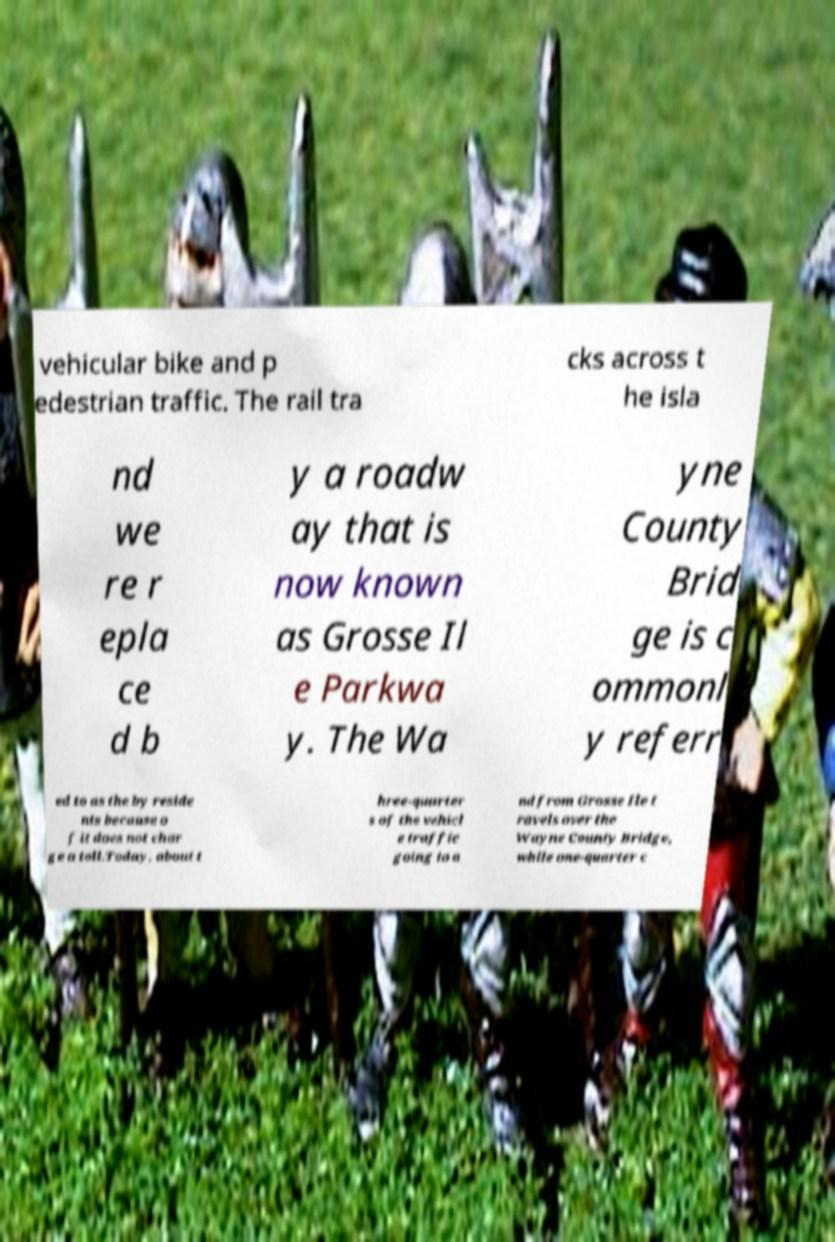Can you read and provide the text displayed in the image?This photo seems to have some interesting text. Can you extract and type it out for me? vehicular bike and p edestrian traffic. The rail tra cks across t he isla nd we re r epla ce d b y a roadw ay that is now known as Grosse Il e Parkwa y. The Wa yne County Brid ge is c ommonl y referr ed to as the by reside nts because o f it does not char ge a toll.Today, about t hree-quarter s of the vehicl e traffic going to a nd from Grosse Ile t ravels over the Wayne County Bridge, while one-quarter c 